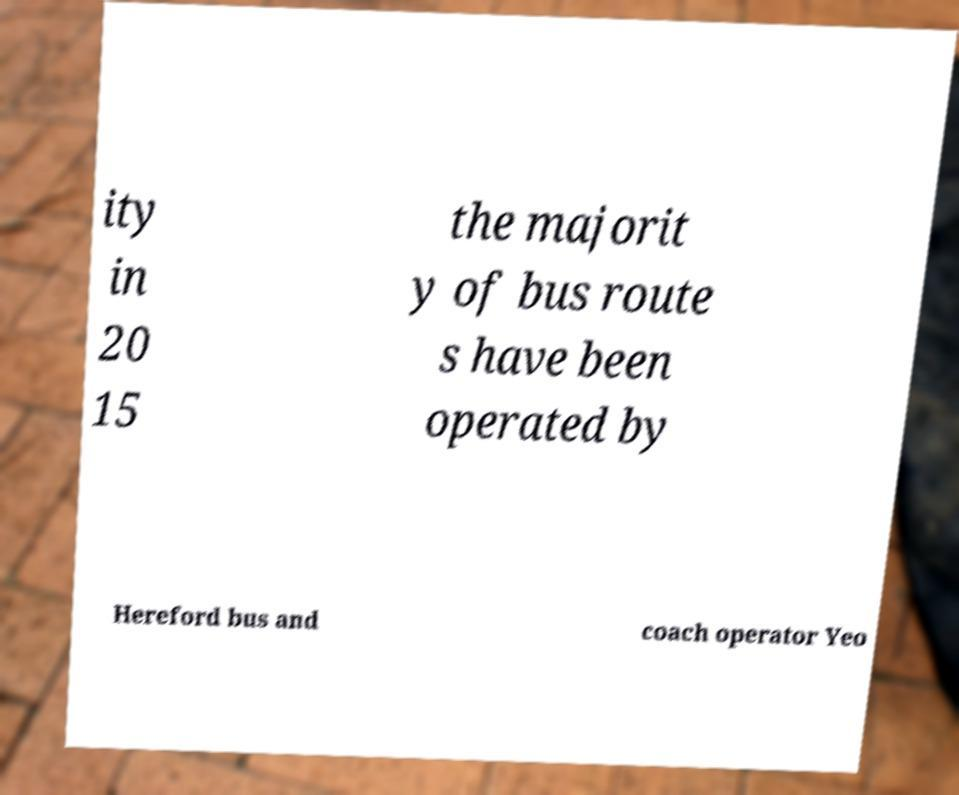What messages or text are displayed in this image? I need them in a readable, typed format. ity in 20 15 the majorit y of bus route s have been operated by Hereford bus and coach operator Yeo 